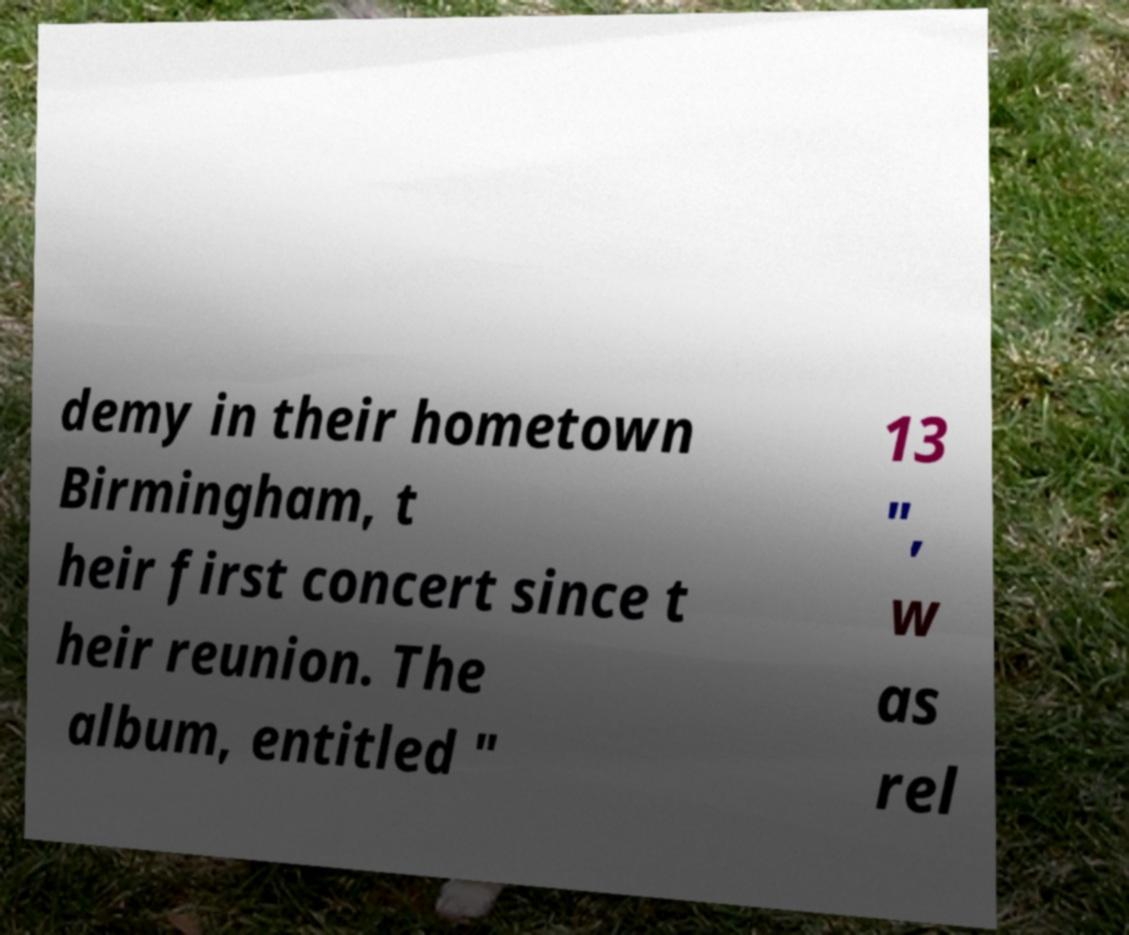Please read and relay the text visible in this image. What does it say? demy in their hometown Birmingham, t heir first concert since t heir reunion. The album, entitled " 13 ", w as rel 